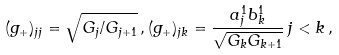<formula> <loc_0><loc_0><loc_500><loc_500>( g _ { + } ) _ { j j } = \sqrt { G _ { j } / G _ { j + 1 } } \, , ( g _ { + } ) _ { j k } = \frac { a _ { j } ^ { 1 } b _ { k } ^ { 1 } } { \sqrt { G _ { k } G _ { k + 1 } } } \, j < k \, ,</formula> 